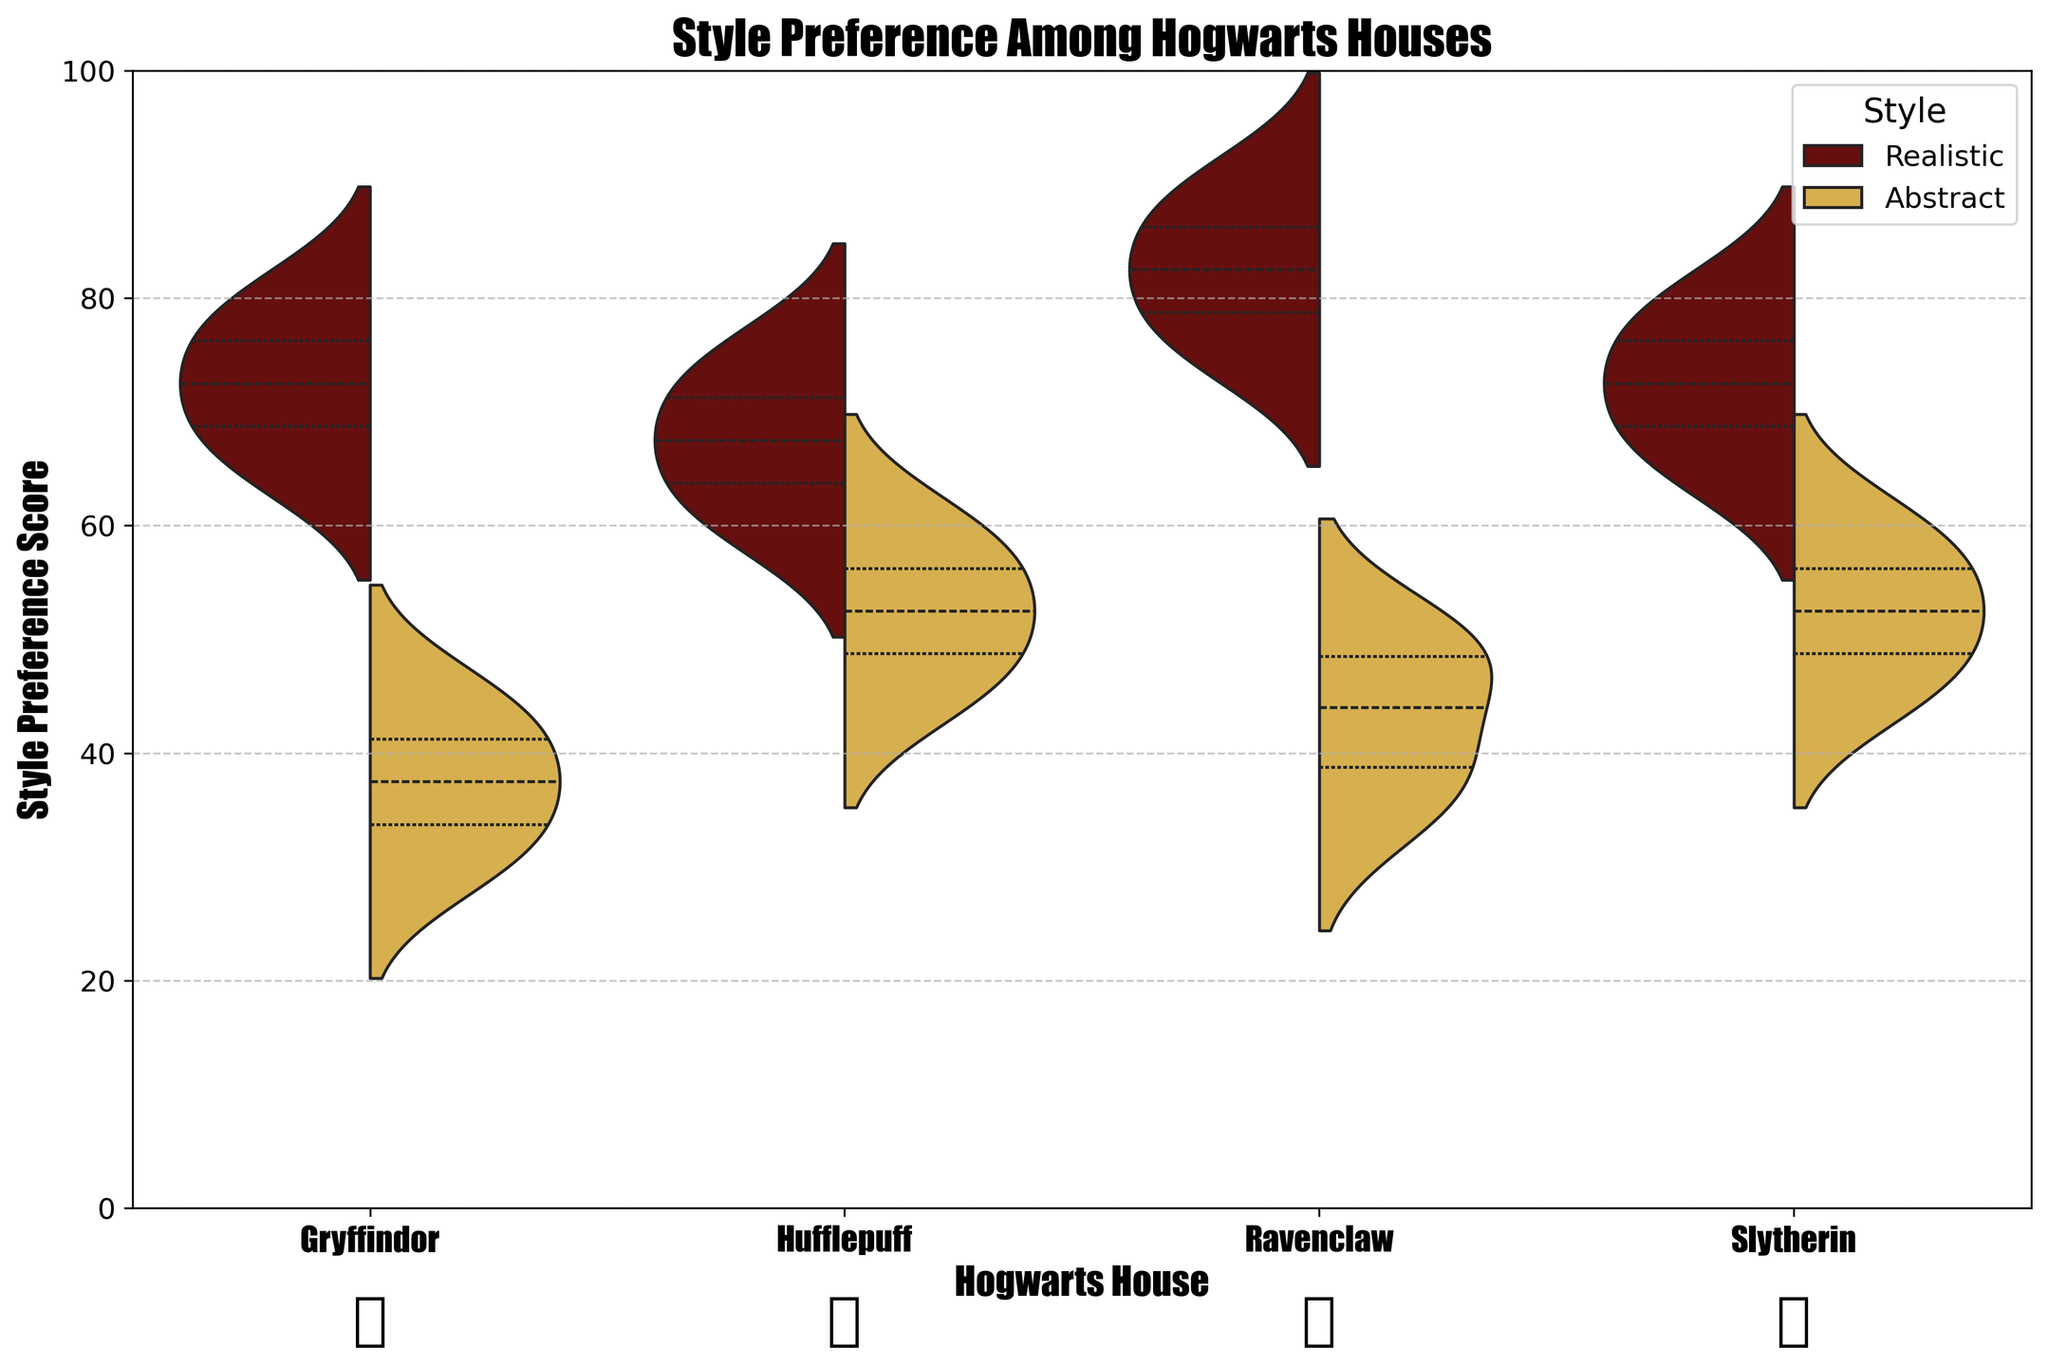What is the title of the plot? The title is displayed at the top of the plot in bold and larger font size. It summarizes the main theme of the plot.
Answer: Style Preference Among Hogwarts Houses Which Hogwarts house shows the most variation in realistic style preference? To determine the variation, observe the spread of the violin plot for realistic style within each house. The wider the spread, the greater the variation.
Answer: Ravenclaw What is the median value for abstract style preference in Hufflepuff? The median of the abstract style preference can be found by looking at the white dot in the middle of the "abstract" section of the violin plot.
Answer: 52.5 How do the median values for realistic style preference compare between Gryffindor and Slytherin? Locate the white dots in the middle of the "realistic" sections for both Gryffindor and Slytherin. Compare these median values.
Answer: Slytherin > Gryffindor Which house has the highest average score for abstract style preference? Look at the center line inside the abstract style sections for each house. The house with the center line closer to the top has the highest average score.
Answer: Slytherin Which house's fans prefer realistic style the most on average? Compare the locations of the white dots in the middle of the realistic sections across all houses. The highest dot indicates the highest average preference.
Answer: Ravenclaw Are there any houses where the realistic and abstract preferences overlap significantly? Check where the violin plots of realistic and abstract styles are merged or overlap significantly. This indicates similar distribution ranges.
Answer: Slytherin What is the range of abstract style preference among Gryffindor fans? Observe the lowest and highest points in the abstract section of Gryffindor's violin plot. The range is the difference between these values.
Answer: 30 to 45 How does the variability in abstract style preference of Hufflepuff compare to that of Ravenclaw? The spread of the abstract section in the violin plots of Hufflepuff and Ravenclaw should be compared to determine variability. Wider curves indicate higher variability.
Answer: Hufflepuff < Ravenclaw What is the general trend of style preferences among Ravenclaw fans? Analyze the spread and central tendencies of both realistic and abstract sections in Ravenclaw's violin plot. Compare their medians and spreads.
Answer: Prefer realistic 